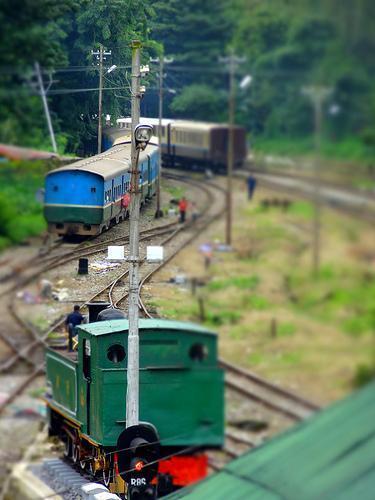How many train cars are shown?
Give a very brief answer. 3. 